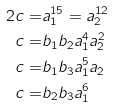<formula> <loc_0><loc_0><loc_500><loc_500>{ 2 } c = & a _ { 1 } ^ { 1 5 } = a _ { 2 } ^ { 1 2 } \\ c = & b _ { 1 } b _ { 2 } a _ { 1 } ^ { 4 } a _ { 2 } ^ { 2 } \\ c = & b _ { 1 } b _ { 3 } a _ { 1 } ^ { 5 } a _ { 2 } \\ c = & b _ { 2 } b _ { 3 } a _ { 1 } ^ { 6 } \\</formula> 